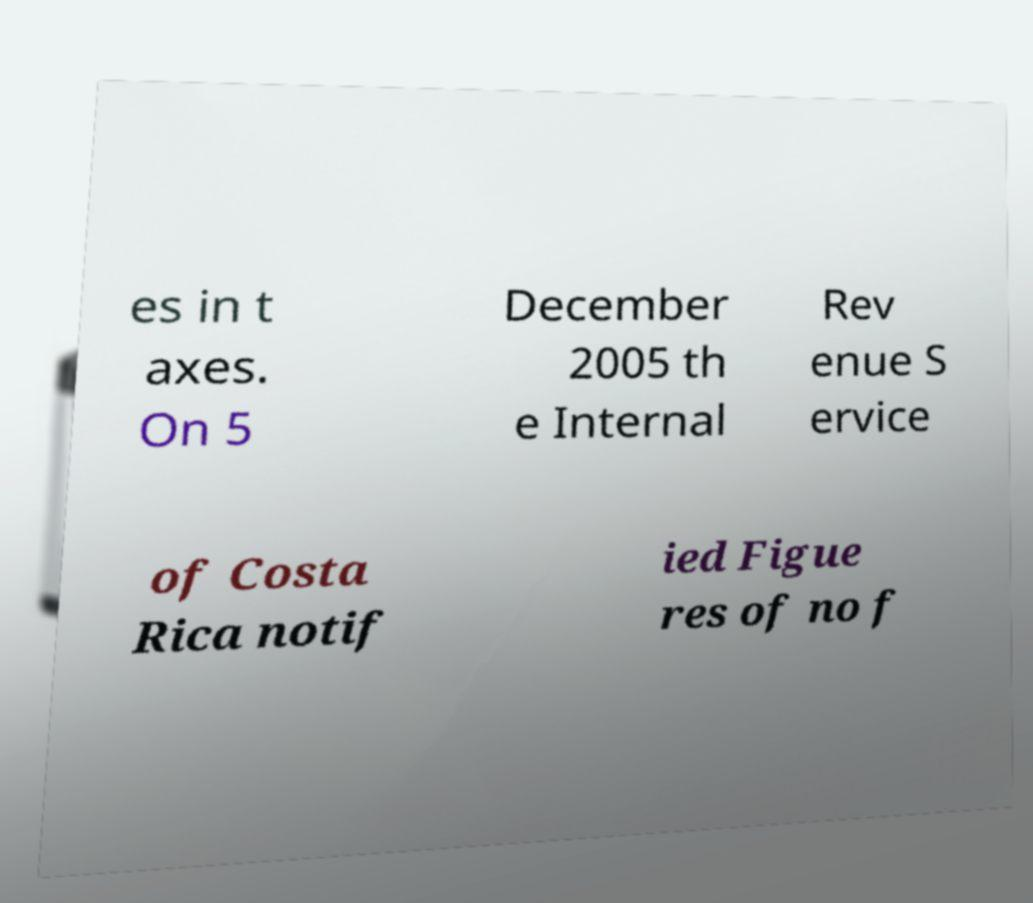Can you read and provide the text displayed in the image?This photo seems to have some interesting text. Can you extract and type it out for me? es in t axes. On 5 December 2005 th e Internal Rev enue S ervice of Costa Rica notif ied Figue res of no f 